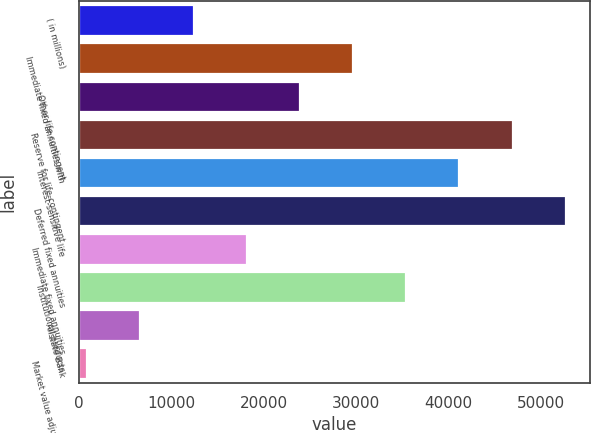<chart> <loc_0><loc_0><loc_500><loc_500><bar_chart><fcel>( in millions)<fcel>Immediate fixed annuities with<fcel>Other life contingent<fcel>Reserve for life-contingent<fcel>Interest-sensitive life<fcel>Deferred fixed annuities<fcel>Immediate fixed annuities<fcel>Institutional products<fcel>Allstate Bank<fcel>Market value adjustments<nl><fcel>12381<fcel>29643<fcel>23889<fcel>46905<fcel>41151<fcel>52659<fcel>18135<fcel>35397<fcel>6627<fcel>873<nl></chart> 